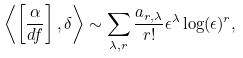<formula> <loc_0><loc_0><loc_500><loc_500>\left \langle \left [ \frac { \alpha } { d f } \right ] , \delta \right \rangle \sim \sum _ { \lambda , r } \frac { a _ { r , \lambda } } { r ! } \epsilon ^ { \lambda } \log ( \epsilon ) ^ { r } ,</formula> 